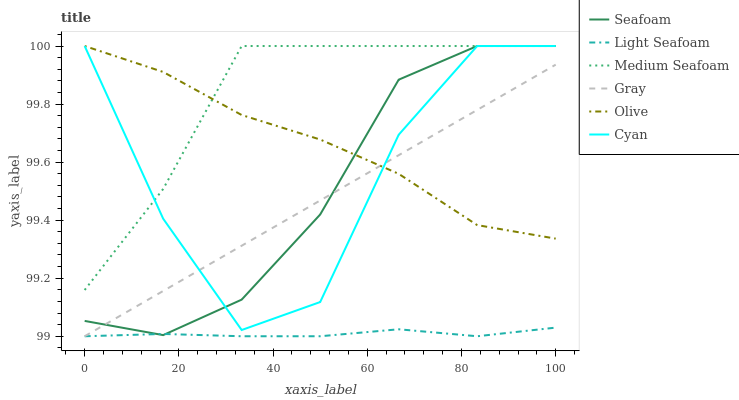Does Seafoam have the minimum area under the curve?
Answer yes or no. No. Does Seafoam have the maximum area under the curve?
Answer yes or no. No. Is Seafoam the smoothest?
Answer yes or no. No. Is Seafoam the roughest?
Answer yes or no. No. Does Seafoam have the lowest value?
Answer yes or no. No. Does Light Seafoam have the highest value?
Answer yes or no. No. Is Gray less than Medium Seafoam?
Answer yes or no. Yes. Is Medium Seafoam greater than Gray?
Answer yes or no. Yes. Does Gray intersect Medium Seafoam?
Answer yes or no. No. 